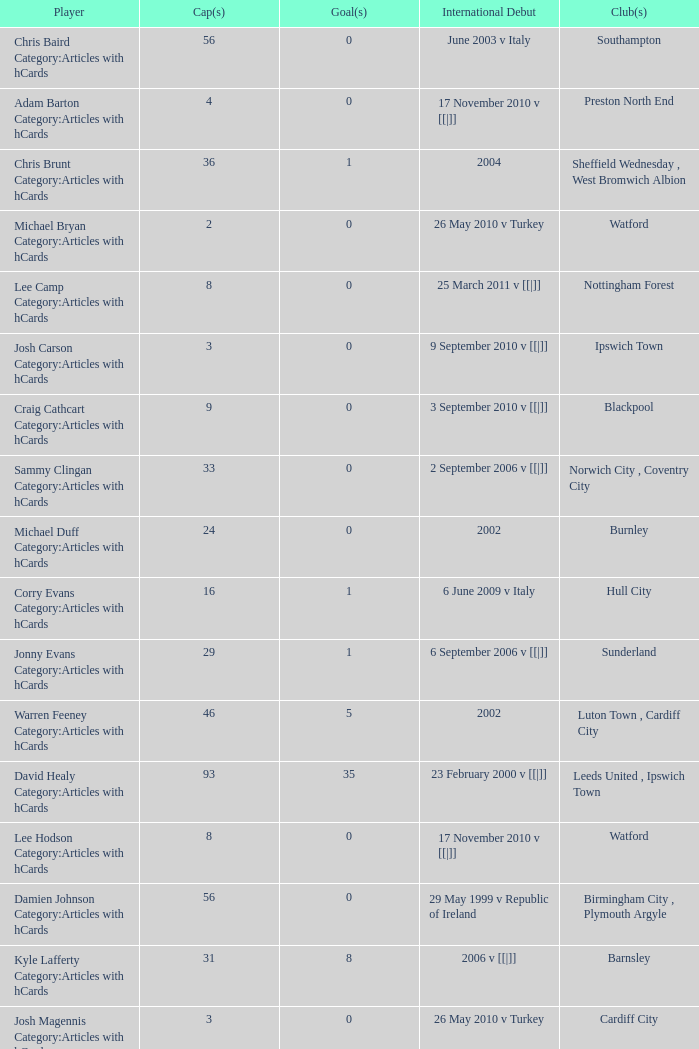Can you parse all the data within this table? {'header': ['Player', 'Cap(s)', 'Goal(s)', 'International Debut', 'Club(s)'], 'rows': [['Chris Baird Category:Articles with hCards', '56', '0', 'June 2003 v Italy', 'Southampton'], ['Adam Barton Category:Articles with hCards', '4', '0', '17 November 2010 v [[|]]', 'Preston North End'], ['Chris Brunt Category:Articles with hCards', '36', '1', '2004', 'Sheffield Wednesday , West Bromwich Albion'], ['Michael Bryan Category:Articles with hCards', '2', '0', '26 May 2010 v Turkey', 'Watford'], ['Lee Camp Category:Articles with hCards', '8', '0', '25 March 2011 v [[|]]', 'Nottingham Forest'], ['Josh Carson Category:Articles with hCards', '3', '0', '9 September 2010 v [[|]]', 'Ipswich Town'], ['Craig Cathcart Category:Articles with hCards', '9', '0', '3 September 2010 v [[|]]', 'Blackpool'], ['Sammy Clingan Category:Articles with hCards', '33', '0', '2 September 2006 v [[|]]', 'Norwich City , Coventry City'], ['Michael Duff Category:Articles with hCards', '24', '0', '2002', 'Burnley'], ['Corry Evans Category:Articles with hCards', '16', '1', '6 June 2009 v Italy', 'Hull City'], ['Jonny Evans Category:Articles with hCards', '29', '1', '6 September 2006 v [[|]]', 'Sunderland'], ['Warren Feeney Category:Articles with hCards', '46', '5', '2002', 'Luton Town , Cardiff City'], ['David Healy Category:Articles with hCards', '93', '35', '23 February 2000 v [[|]]', 'Leeds United , Ipswich Town'], ['Lee Hodson Category:Articles with hCards', '8', '0', '17 November 2010 v [[|]]', 'Watford'], ['Damien Johnson Category:Articles with hCards', '56', '0', '29 May 1999 v Republic of Ireland', 'Birmingham City , Plymouth Argyle'], ['Kyle Lafferty Category:Articles with hCards', '31', '8', '2006 v [[|]]', 'Barnsley'], ['Josh Magennis Category:Articles with hCards', '3', '0', '26 May 2010 v Turkey', 'Cardiff City'], ['Gareth McAuley Category:Articles with hCards', '36', '2', '4 June 2005 v [[|]]', 'Leicester City , Ipswich Town'], ['Grant McCann Category:Articles with hCards', '39', '4', '24 March 2007 v [[|]]', 'Barnsley , Scunthorpe United , Peterborough United'], ['George McCartney Category:Articles with hCards', '34', '1', 'September 2001 v [[|]]', 'Sunderland'], ['Ryan McGivern Category:Articles with hCards', '16', '0', '21 August 2008 v [[|]]', 'Leicester City , Bristol City'], ['James McPake Category:Articles with hCards', '1', '0', '2 June 2012 v [[|]]', 'Coventry City'], ['Josh McQuoid Category:Articles with hCards', '5', '0', '17 November 2010 v [[|]]', 'Millwall'], ['Oliver Norwood Category:Articles with hCards', '6', '0', '11 August 2010 v [[|]]', 'Coventry City'], ["Michael O'Connor Category:Articles with hCards", '10', '0', '26 March 2008 v [[|]]', 'Scunthorpe United'], ['Martin Paterson Category:Articles with hCards', '13', '0', '2007', 'Scunthorpe United , Burnley'], ['Rory Patterson Category:Articles with hCards', '5', '1', '3 March 2010 v [[|]]', 'Plymouth Argyle'], ['Dean Shiels Category:Articles with hCards', '9', '0', '15 November 2005 v [[|]]', 'Doncaster Rovers'], ['Ivan Sproule Category:Articles with hCards', '11', '1', '7 September 2005 v England', 'Bristol City'], ['Maik Taylor Category:Articles with hCards', '88', '0', '27 March 1999 v [[|]]', 'Birmingham City'], ['Adam Thompson Category:Articles with hCards', '2', '0', '9 February 2011 v [[|]]', 'Watford']]} How many participants had 8 goals? 1.0. 